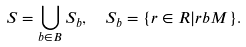Convert formula to latex. <formula><loc_0><loc_0><loc_500><loc_500>S = \bigcup _ { b \in B } S _ { b } , \ \ S _ { b } = \{ r \in R | r b M \} .</formula> 